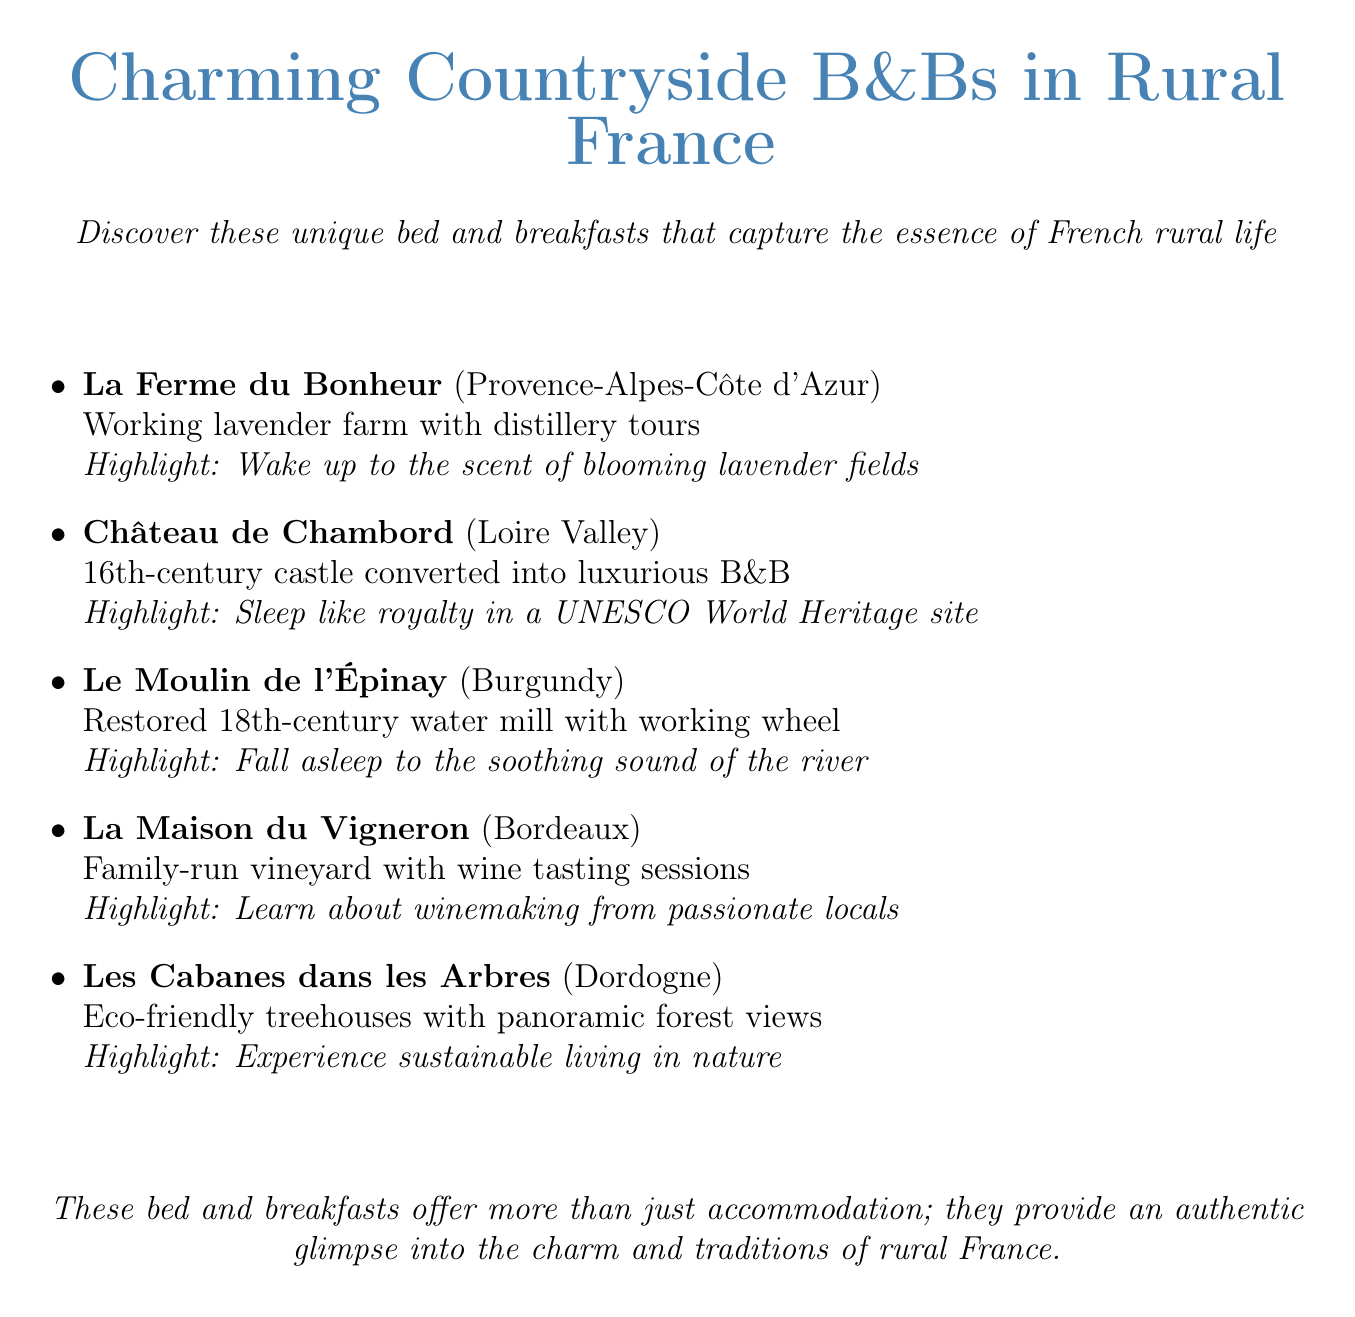What is the name of the B&B in Provence-Alpes-Côte d'Azur? The name listed is La Ferme du Bonheur.
Answer: La Ferme du Bonheur What unique feature is associated with Château de Chambord? The document states it is a 16th-century castle converted into luxurious B&B.
Answer: 16th-century castle converted into luxurious B&B What highlight is mentioned for Le Moulin de l'Épinay? The highlight is about falling asleep to the soothing sound of the river.
Answer: Fall asleep to the soothing sound of the river Which region is La Maison du Vigneron located in? The document specifies it is located in Bordeaux.
Answer: Bordeaux How many unique B&Bs are recommended in the document? The document lists a total of five unique B&Bs.
Answer: Five What aspect of the B&Bs do they aim to provide, according to the conclusion? The conclusion mentions providing an authentic glimpse into the charm and traditions of rural France.
Answer: Authentic glimpse into the charm and traditions of rural France What is a unique feature of Les Cabanes dans les Arbres? The document describes it as eco-friendly treehouses with panoramic forest views.
Answer: Eco-friendly treehouses with panoramic forest views In which region can you find a family-run vineyard offering wine tasting sessions? The document identifies Bordeaux as the region for a family-run vineyard.
Answer: Bordeaux 